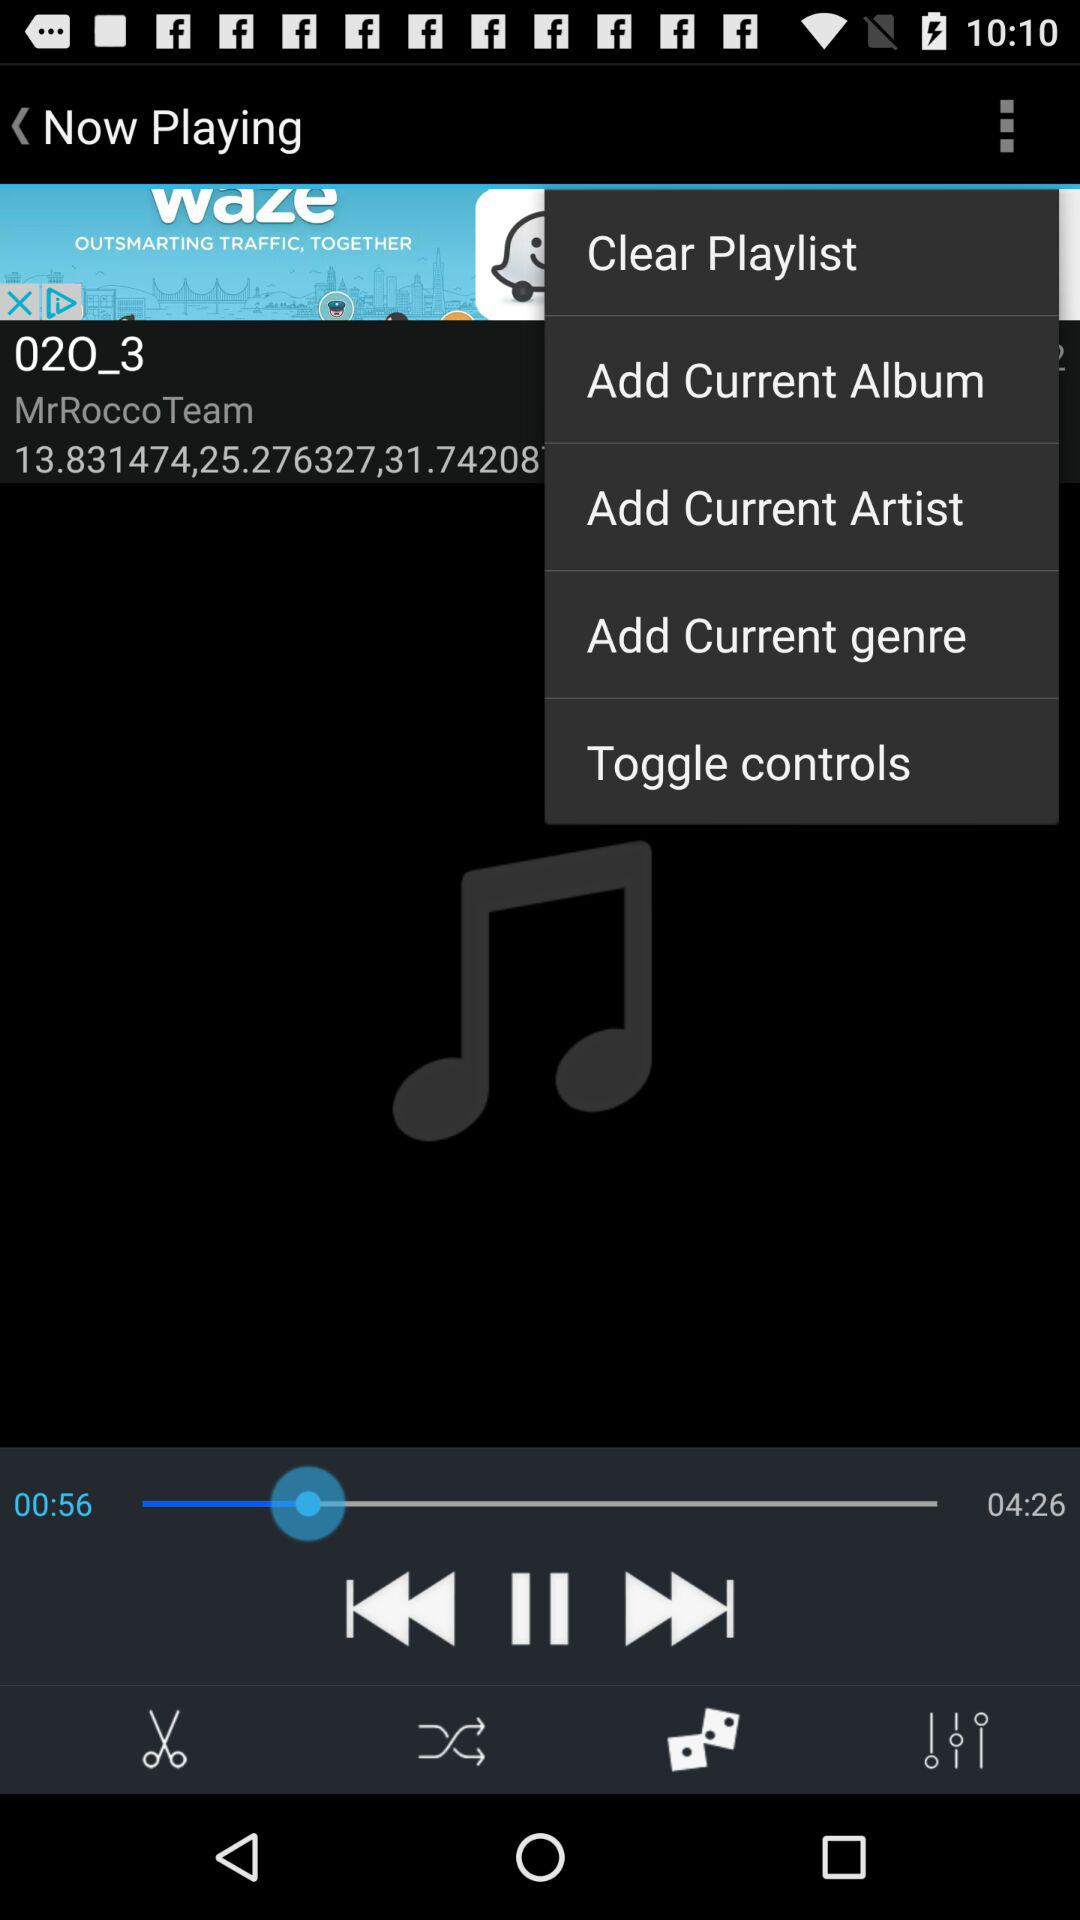How much audio is finished? The audio is finished till 00:56 seconds. 